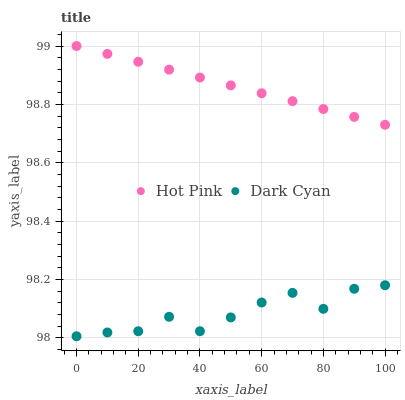Does Dark Cyan have the minimum area under the curve?
Answer yes or no. Yes. Does Hot Pink have the maximum area under the curve?
Answer yes or no. Yes. Does Hot Pink have the minimum area under the curve?
Answer yes or no. No. Is Hot Pink the smoothest?
Answer yes or no. Yes. Is Dark Cyan the roughest?
Answer yes or no. Yes. Is Hot Pink the roughest?
Answer yes or no. No. Does Dark Cyan have the lowest value?
Answer yes or no. Yes. Does Hot Pink have the lowest value?
Answer yes or no. No. Does Hot Pink have the highest value?
Answer yes or no. Yes. Is Dark Cyan less than Hot Pink?
Answer yes or no. Yes. Is Hot Pink greater than Dark Cyan?
Answer yes or no. Yes. Does Dark Cyan intersect Hot Pink?
Answer yes or no. No. 